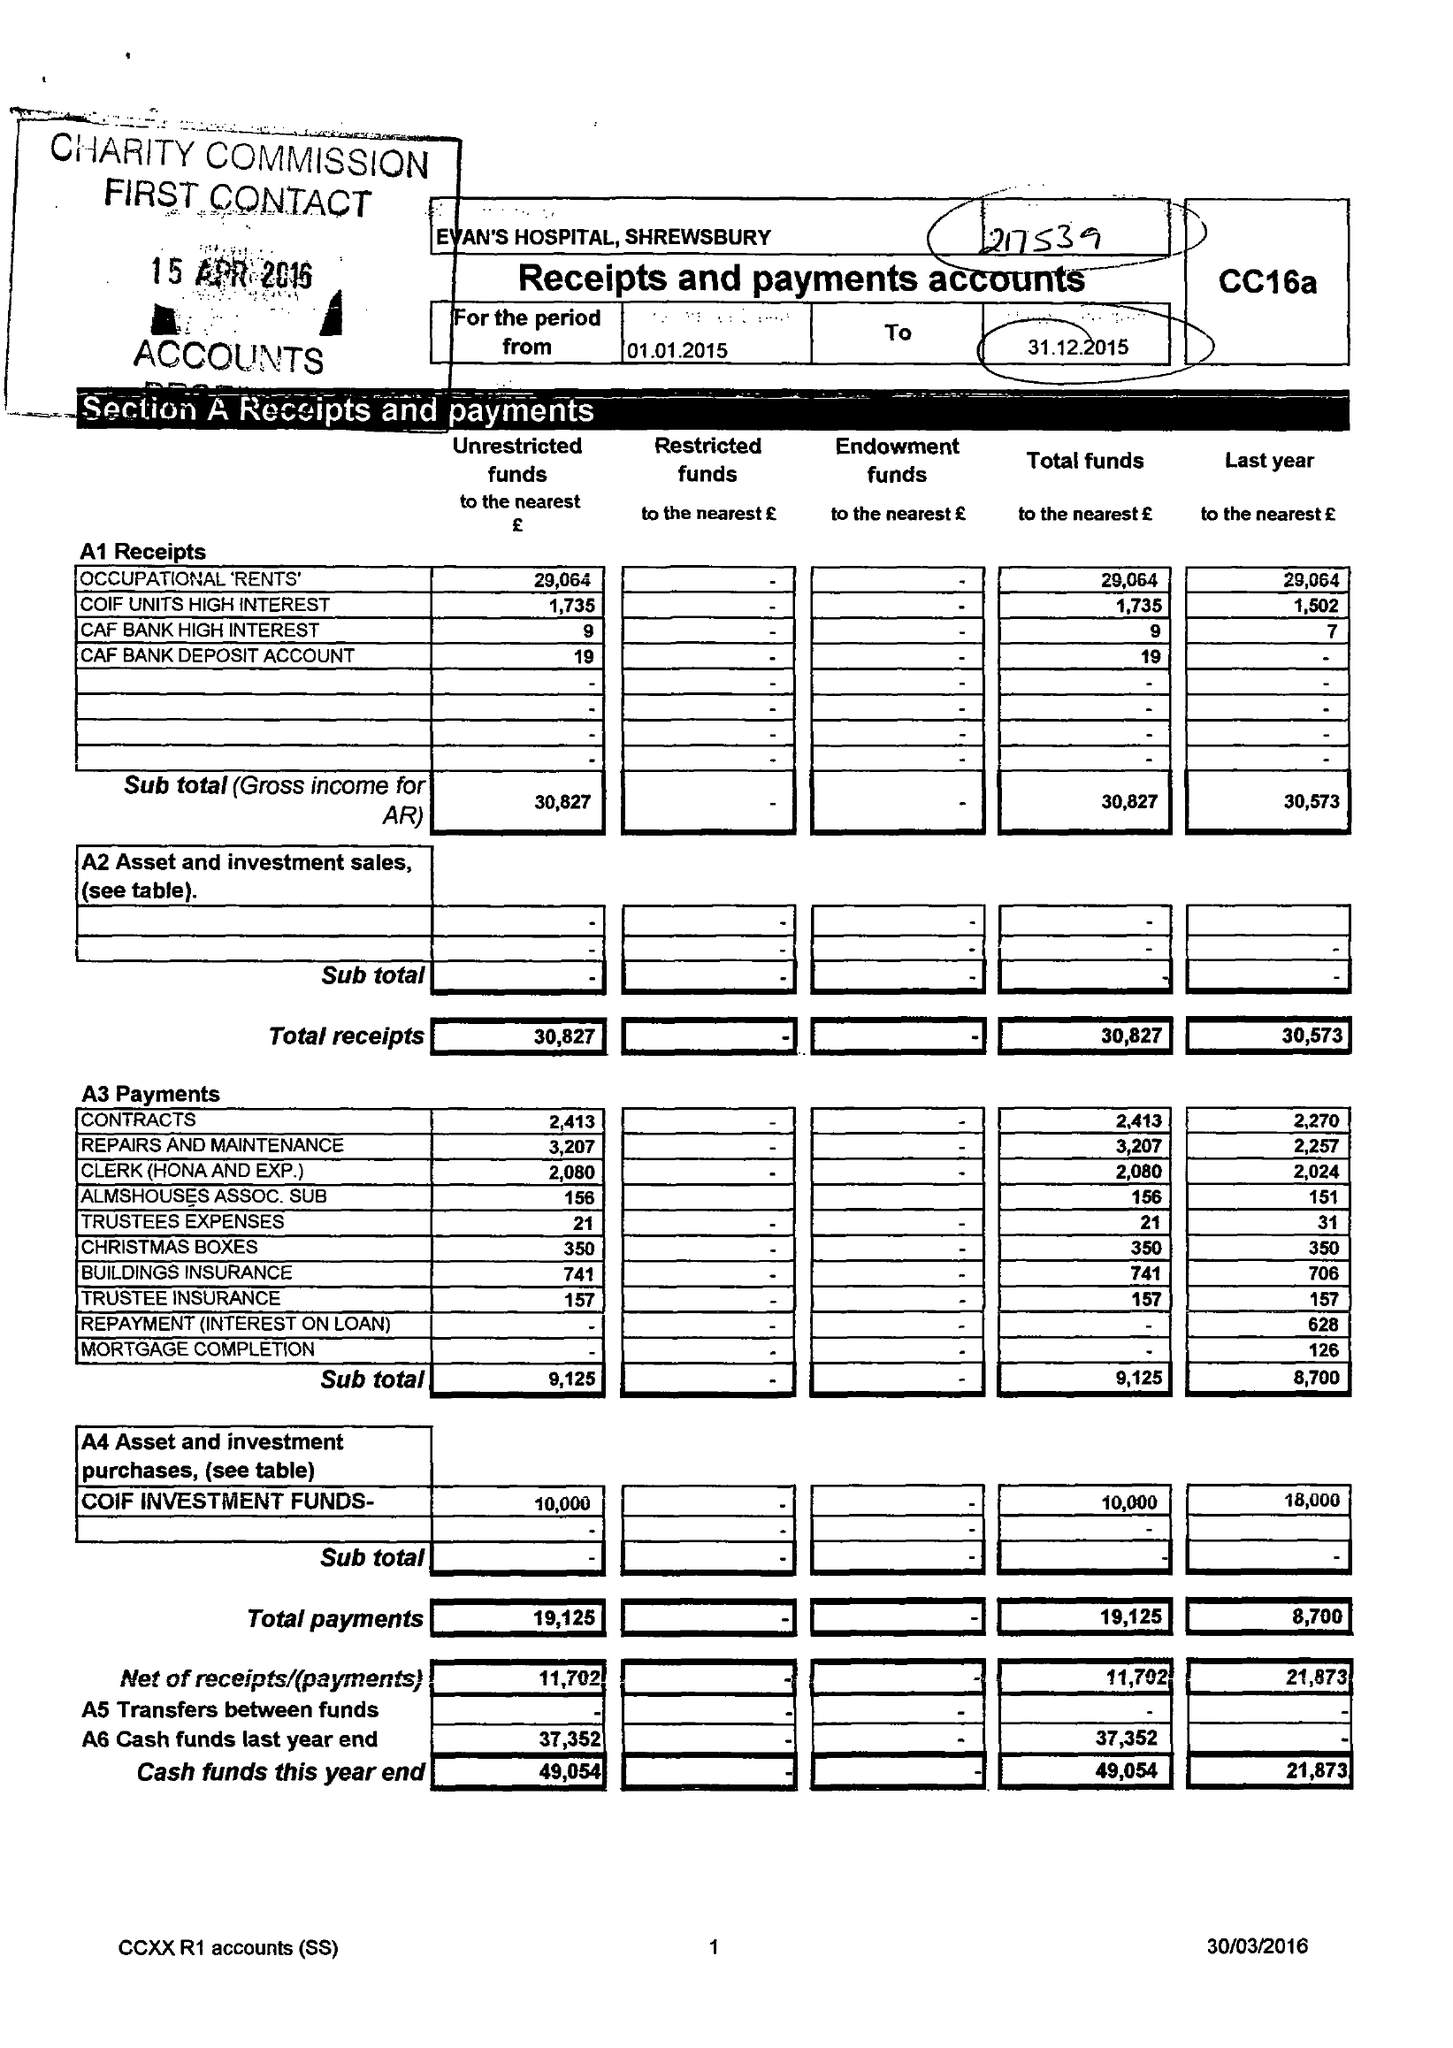What is the value for the income_annually_in_british_pounds?
Answer the question using a single word or phrase. 30827.00 